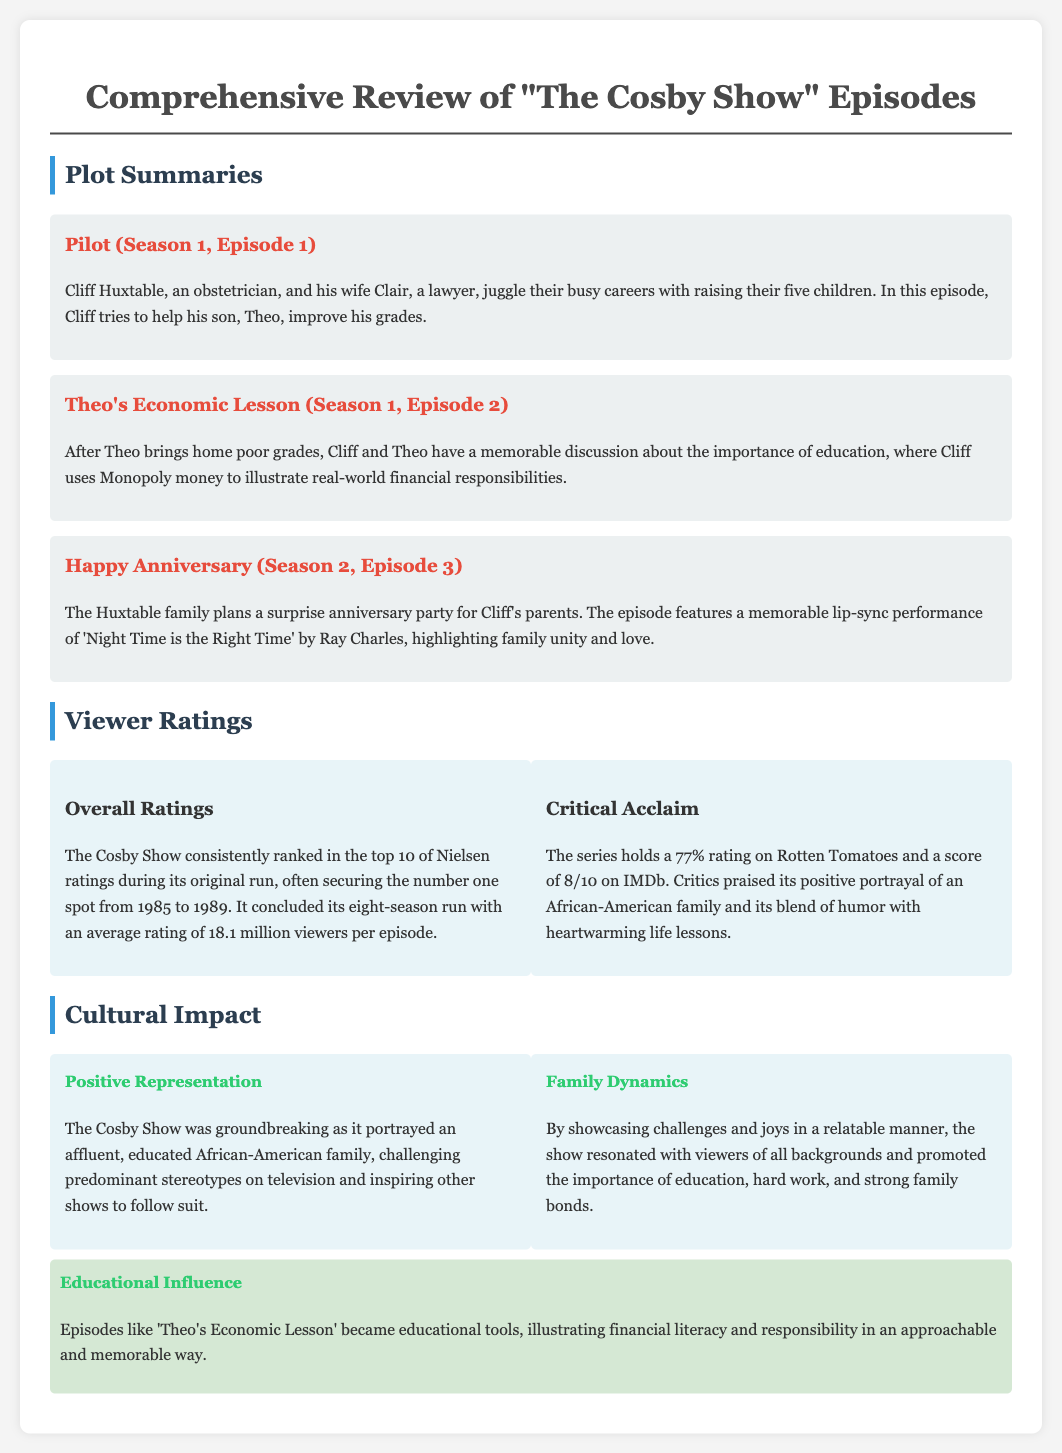What is the average viewer rating of "The Cosby Show"? The average viewer rating is stated as 18.1 million viewers per episode, based on its eight-season run.
Answer: 18.1 million viewers What episode features a financial lesson using Monopoly money? The episode titled "Theo's Economic Lesson" focuses on teaching Theo about the importance of education and finances with Monopoly money.
Answer: Theo's Economic Lesson In what years did "The Cosby Show" secure the number one spot in Nielsen ratings? The show consistently secured the number one spot from 1985 to 1989 during its original run.
Answer: 1985 to 1989 What is the Rotten Tomatoes rating for "The Cosby Show"? The document indicates that the series holds a 77% rating on Rotten Tomatoes.
Answer: 77% Which character is an obstetrician? The main character Cliff Huxtable, who helps raise his five children, is an obstetrician.
Answer: Cliff Huxtable What song does Ray Charles perform in the anniversary episode? The memorable song performed by Ray Charles in the episode “Happy Anniversary” is "Night Time is the Right Time."
Answer: Night Time is the Right Time What cultural impact did "The Cosby Show" have on television? The show was groundbreaking for portraying an affluent, educated African-American family, challenging stereotypes.
Answer: Positive Representation How did "The Cosby Show" influence educational themes? Episodes like "Theo's Economic Lesson" served as educational tools illustrating financial literacy and responsibility.
Answer: Educational Influence What is the critical score of "The Cosby Show" on IMDb? The document mentions that the series has a score of 8/10 on IMDb, indicating its critical acclaim.
Answer: 8/10 